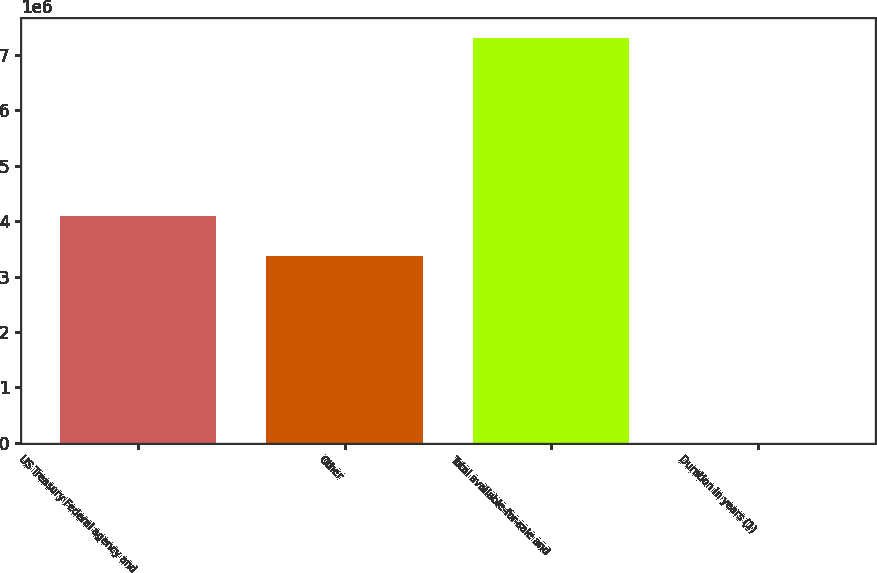Convert chart to OTSL. <chart><loc_0><loc_0><loc_500><loc_500><bar_chart><fcel>US Treasury Federal agency and<fcel>Other<fcel>Total available-for-sale and<fcel>Duration in years (1)<nl><fcel>4.10191e+06<fcel>3.37104e+06<fcel>7.30875e+06<fcel>4.2<nl></chart> 